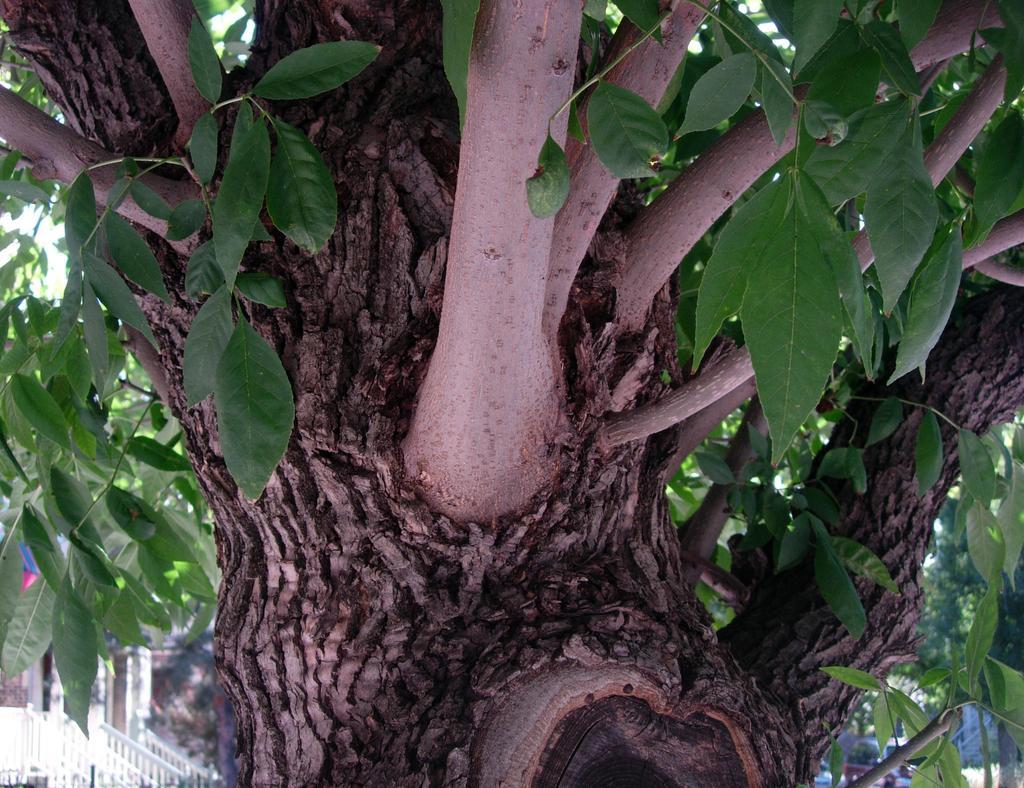Could you give a brief overview of what you see in this image? In the image we can see a tree with tree branches and leaves. We can even see there is a vehicle and this is a fence. 